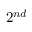Convert formula to latex. <formula><loc_0><loc_0><loc_500><loc_500>2 ^ { n d }</formula> 